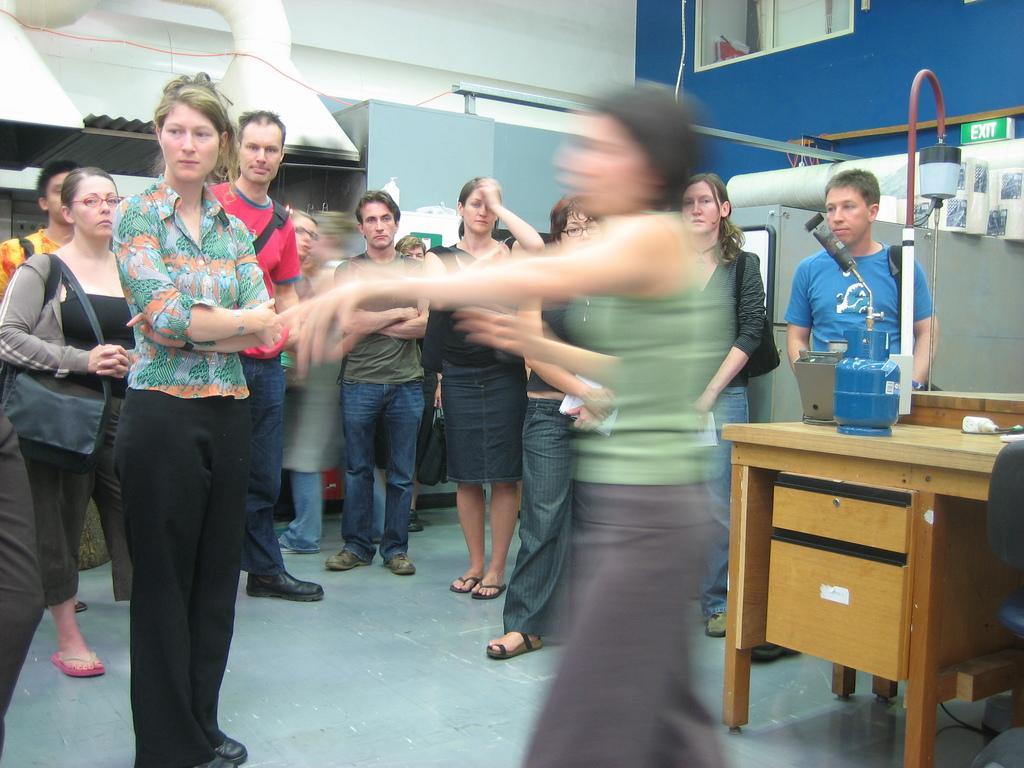In one or two sentences, can you explain what this image depicts? This image is taken indoors. At the bottom of the image there is a floor. In the background there is a wall and there are a few cupboards and there are a few things. At the top of the image there is a ceiling and there is a chimney. On the right side of the image there is a table with a few things on it and there is a sign board. A man is standing on the floor. In the middle of the image a few people are standing on the floor and a woman is walking. 